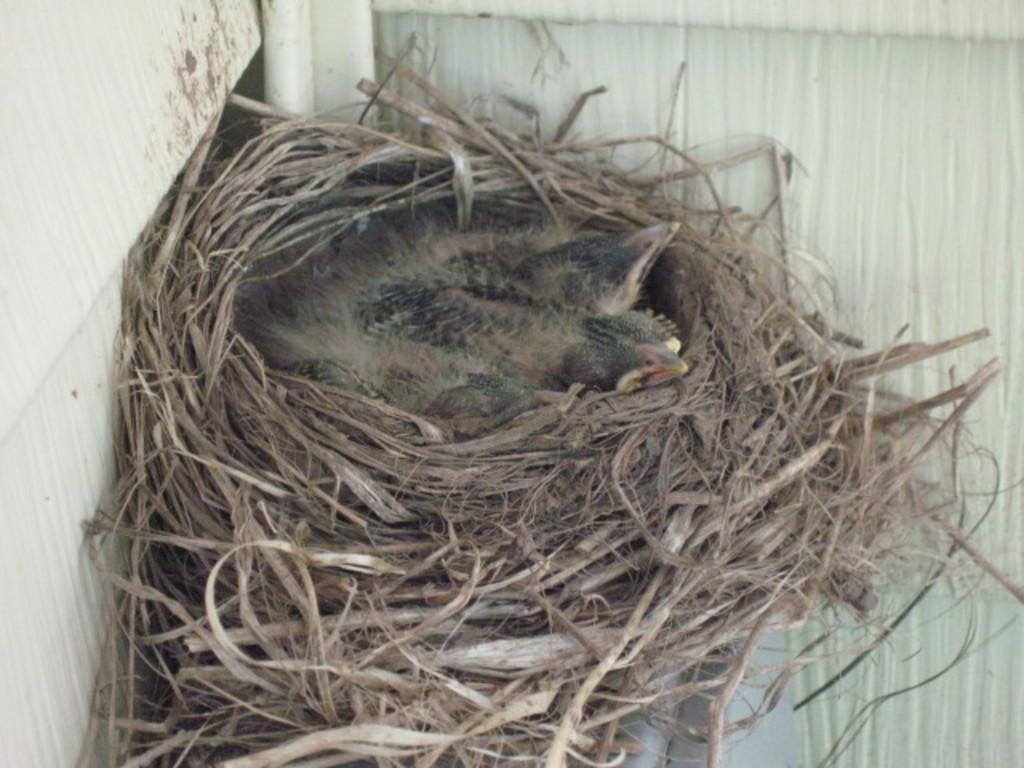In one or two sentences, can you explain what this image depicts? In this image we can see birds in the nest. 